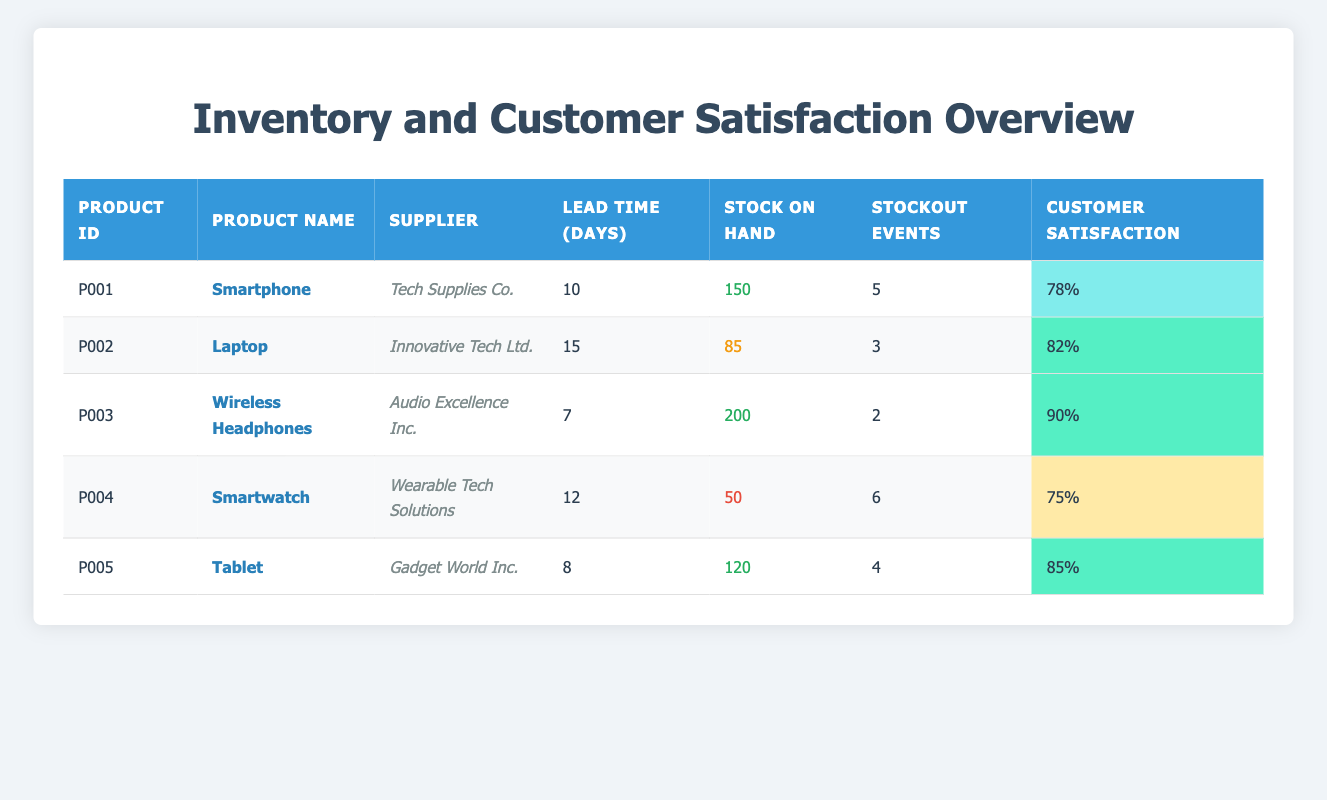What is the customer satisfaction rating for the Wireless Headphones? The table lists the customer satisfaction rating for each product. For the Wireless Headphones, it states the rating as 90%.
Answer: 90% Which product has the highest stock on hand? The table presents the stock on hand for each product. Upon reviewing, the Wireless Headphones have the highest stock at 200 units.
Answer: Wireless Headphones What is the total number of stockout events for all products? To find the total stockout events, we sum the stockout events from each product: 5 + 3 + 2 + 6 + 4 = 20.
Answer: 20 Is the customer satisfaction rating for the Smartwatch higher than that for the Tablet? The Smartwatch has a customer satisfaction rating of 75%, and the Tablet has a rating of 85%. Since 75% is less than 85%, the statement is false.
Answer: No What is the average lead time for the products listed? We first find the lead times for all products: 10, 15, 7, 12, and 8 days. Adding them gives 10 + 15 + 7 + 12 + 8 = 52 days, and since there are 5 products, we divide 52 by 5 to get an average of 10.4 days.
Answer: 10.4 days Which product has the lowest customer satisfaction rating and how many stockout events did it have? According to the table, the Smartwatch has the lowest customer satisfaction rating at 75% and recorded 6 stockout events.
Answer: Smartwatch, 6 stockout events Is the lead time for the Tablet less than that for the Laptop? The lead time for the Tablet is 8 days, while for the Laptop it is 15 days. Thus, 8 is less than 15, making the statement true.
Answer: Yes What is the difference in customer satisfaction ratings between the Smartphone and the Laptop? The Smartphone has a rating of 78%, and the Laptop has a rating of 82%. The difference is calculated as 82 - 78 = 4%.
Answer: 4% 